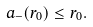Convert formula to latex. <formula><loc_0><loc_0><loc_500><loc_500>a _ { - } ( r _ { 0 } ) \leq r _ { 0 } .</formula> 